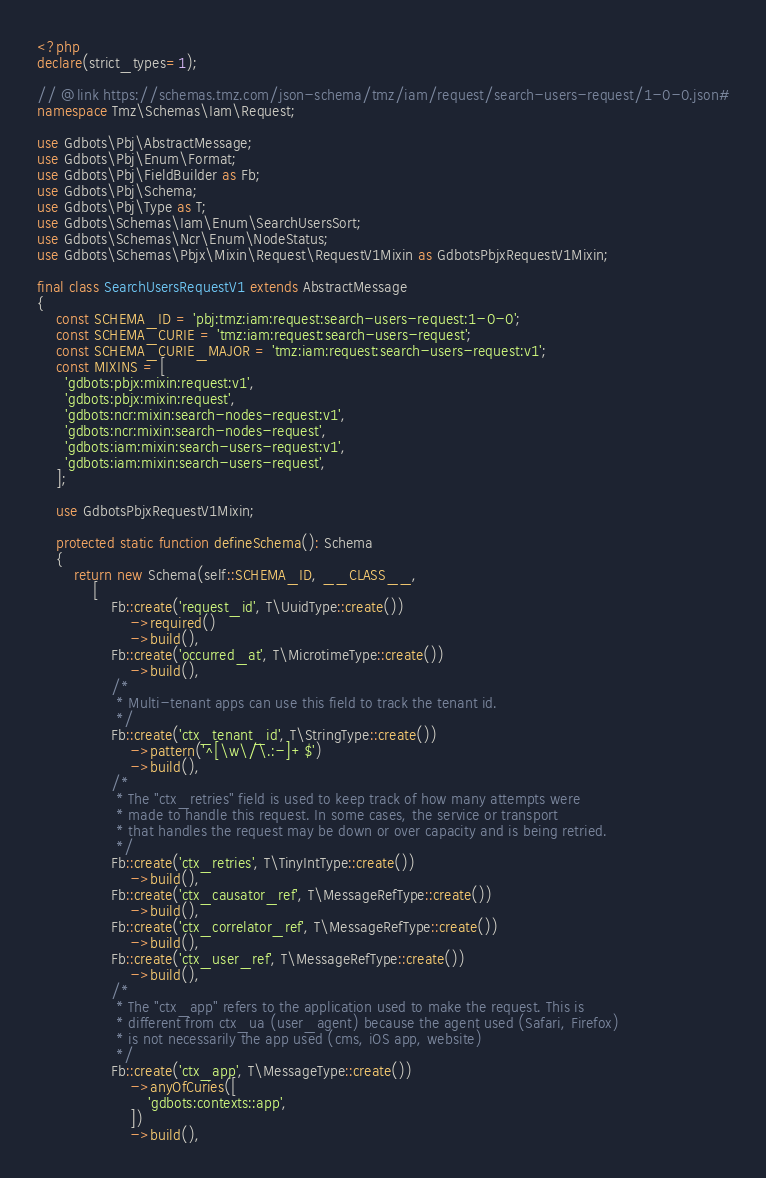<code> <loc_0><loc_0><loc_500><loc_500><_PHP_><?php
declare(strict_types=1);

// @link https://schemas.tmz.com/json-schema/tmz/iam/request/search-users-request/1-0-0.json#
namespace Tmz\Schemas\Iam\Request;

use Gdbots\Pbj\AbstractMessage;
use Gdbots\Pbj\Enum\Format;
use Gdbots\Pbj\FieldBuilder as Fb;
use Gdbots\Pbj\Schema;
use Gdbots\Pbj\Type as T;
use Gdbots\Schemas\Iam\Enum\SearchUsersSort;
use Gdbots\Schemas\Ncr\Enum\NodeStatus;
use Gdbots\Schemas\Pbjx\Mixin\Request\RequestV1Mixin as GdbotsPbjxRequestV1Mixin;

final class SearchUsersRequestV1 extends AbstractMessage
{
    const SCHEMA_ID = 'pbj:tmz:iam:request:search-users-request:1-0-0';
    const SCHEMA_CURIE = 'tmz:iam:request:search-users-request';
    const SCHEMA_CURIE_MAJOR = 'tmz:iam:request:search-users-request:v1';
    const MIXINS = [
      'gdbots:pbjx:mixin:request:v1',
      'gdbots:pbjx:mixin:request',
      'gdbots:ncr:mixin:search-nodes-request:v1',
      'gdbots:ncr:mixin:search-nodes-request',
      'gdbots:iam:mixin:search-users-request:v1',
      'gdbots:iam:mixin:search-users-request',
    ];

    use GdbotsPbjxRequestV1Mixin;

    protected static function defineSchema(): Schema
    {
        return new Schema(self::SCHEMA_ID, __CLASS__,
            [
                Fb::create('request_id', T\UuidType::create())
                    ->required()
                    ->build(),
                Fb::create('occurred_at', T\MicrotimeType::create())
                    ->build(),
                /*
                 * Multi-tenant apps can use this field to track the tenant id.
                 */
                Fb::create('ctx_tenant_id', T\StringType::create())
                    ->pattern('^[\w\/\.:-]+$')
                    ->build(),
                /*
                 * The "ctx_retries" field is used to keep track of how many attempts were
                 * made to handle this request. In some cases, the service or transport
                 * that handles the request may be down or over capacity and is being retried.
                 */
                Fb::create('ctx_retries', T\TinyIntType::create())
                    ->build(),
                Fb::create('ctx_causator_ref', T\MessageRefType::create())
                    ->build(),
                Fb::create('ctx_correlator_ref', T\MessageRefType::create())
                    ->build(),
                Fb::create('ctx_user_ref', T\MessageRefType::create())
                    ->build(),
                /*
                 * The "ctx_app" refers to the application used to make the request. This is
                 * different from ctx_ua (user_agent) because the agent used (Safari, Firefox)
                 * is not necessarily the app used (cms, iOS app, website)
                 */
                Fb::create('ctx_app', T\MessageType::create())
                    ->anyOfCuries([
                        'gdbots:contexts::app',
                    ])
                    ->build(),</code> 